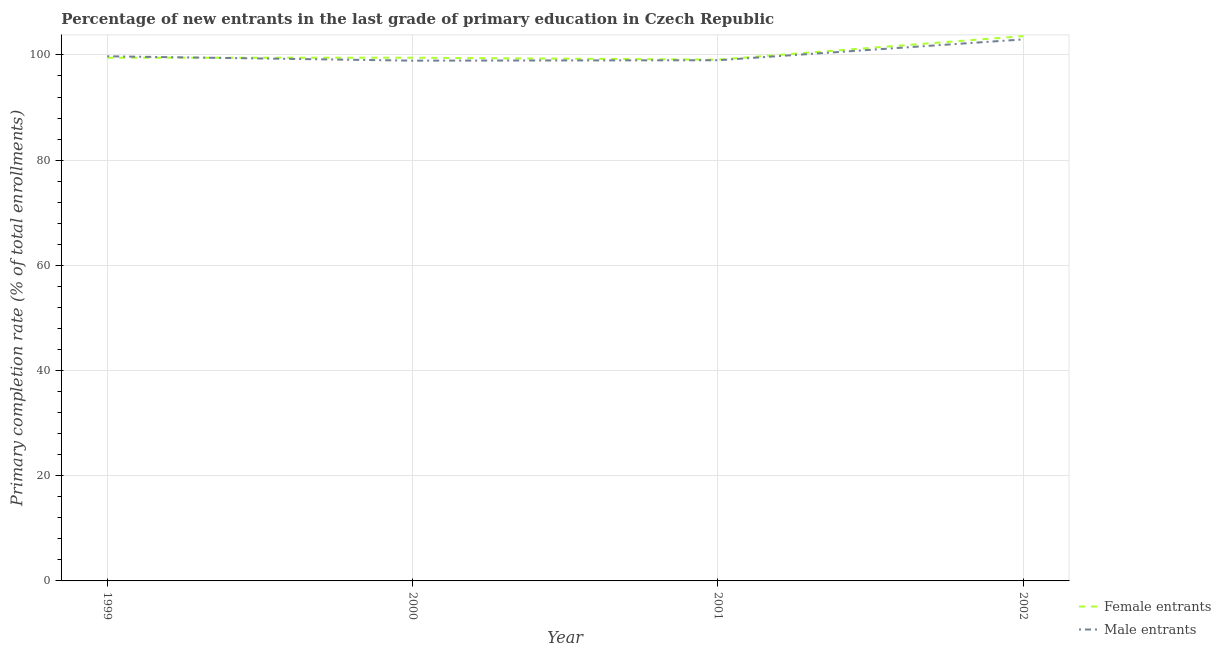Is the number of lines equal to the number of legend labels?
Your answer should be very brief. Yes. What is the primary completion rate of male entrants in 1999?
Offer a terse response. 99.75. Across all years, what is the maximum primary completion rate of female entrants?
Your response must be concise. 103.58. Across all years, what is the minimum primary completion rate of male entrants?
Provide a succinct answer. 98.92. What is the total primary completion rate of female entrants in the graph?
Offer a terse response. 401.64. What is the difference between the primary completion rate of male entrants in 1999 and that in 2001?
Keep it short and to the point. 0.75. What is the difference between the primary completion rate of male entrants in 2000 and the primary completion rate of female entrants in 2001?
Your answer should be compact. -0.19. What is the average primary completion rate of female entrants per year?
Your answer should be very brief. 100.41. In the year 2002, what is the difference between the primary completion rate of female entrants and primary completion rate of male entrants?
Your response must be concise. 0.63. What is the ratio of the primary completion rate of female entrants in 1999 to that in 2002?
Provide a succinct answer. 0.96. What is the difference between the highest and the second highest primary completion rate of female entrants?
Provide a short and direct response. 4.11. What is the difference between the highest and the lowest primary completion rate of male entrants?
Offer a very short reply. 4.04. In how many years, is the primary completion rate of male entrants greater than the average primary completion rate of male entrants taken over all years?
Give a very brief answer. 1. Is the sum of the primary completion rate of male entrants in 2000 and 2002 greater than the maximum primary completion rate of female entrants across all years?
Your answer should be very brief. Yes. Does the primary completion rate of male entrants monotonically increase over the years?
Ensure brevity in your answer.  No. Is the primary completion rate of male entrants strictly greater than the primary completion rate of female entrants over the years?
Give a very brief answer. No. How many lines are there?
Your response must be concise. 2. How many years are there in the graph?
Make the answer very short. 4. Where does the legend appear in the graph?
Your response must be concise. Bottom right. What is the title of the graph?
Give a very brief answer. Percentage of new entrants in the last grade of primary education in Czech Republic. What is the label or title of the Y-axis?
Give a very brief answer. Primary completion rate (% of total enrollments). What is the Primary completion rate (% of total enrollments) in Female entrants in 1999?
Make the answer very short. 99.47. What is the Primary completion rate (% of total enrollments) in Male entrants in 1999?
Make the answer very short. 99.75. What is the Primary completion rate (% of total enrollments) in Female entrants in 2000?
Your response must be concise. 99.47. What is the Primary completion rate (% of total enrollments) of Male entrants in 2000?
Make the answer very short. 98.92. What is the Primary completion rate (% of total enrollments) in Female entrants in 2001?
Make the answer very short. 99.11. What is the Primary completion rate (% of total enrollments) of Male entrants in 2001?
Your answer should be compact. 99. What is the Primary completion rate (% of total enrollments) in Female entrants in 2002?
Give a very brief answer. 103.58. What is the Primary completion rate (% of total enrollments) in Male entrants in 2002?
Give a very brief answer. 102.96. Across all years, what is the maximum Primary completion rate (% of total enrollments) in Female entrants?
Your answer should be very brief. 103.58. Across all years, what is the maximum Primary completion rate (% of total enrollments) in Male entrants?
Provide a succinct answer. 102.96. Across all years, what is the minimum Primary completion rate (% of total enrollments) in Female entrants?
Your response must be concise. 99.11. Across all years, what is the minimum Primary completion rate (% of total enrollments) of Male entrants?
Offer a terse response. 98.92. What is the total Primary completion rate (% of total enrollments) in Female entrants in the graph?
Give a very brief answer. 401.64. What is the total Primary completion rate (% of total enrollments) in Male entrants in the graph?
Offer a terse response. 400.62. What is the difference between the Primary completion rate (% of total enrollments) in Female entrants in 1999 and that in 2000?
Your response must be concise. -0. What is the difference between the Primary completion rate (% of total enrollments) in Male entrants in 1999 and that in 2000?
Provide a short and direct response. 0.83. What is the difference between the Primary completion rate (% of total enrollments) of Female entrants in 1999 and that in 2001?
Your answer should be very brief. 0.36. What is the difference between the Primary completion rate (% of total enrollments) in Male entrants in 1999 and that in 2001?
Your answer should be very brief. 0.75. What is the difference between the Primary completion rate (% of total enrollments) of Female entrants in 1999 and that in 2002?
Ensure brevity in your answer.  -4.11. What is the difference between the Primary completion rate (% of total enrollments) of Male entrants in 1999 and that in 2002?
Make the answer very short. -3.21. What is the difference between the Primary completion rate (% of total enrollments) of Female entrants in 2000 and that in 2001?
Keep it short and to the point. 0.36. What is the difference between the Primary completion rate (% of total enrollments) in Male entrants in 2000 and that in 2001?
Keep it short and to the point. -0.08. What is the difference between the Primary completion rate (% of total enrollments) of Female entrants in 2000 and that in 2002?
Offer a terse response. -4.11. What is the difference between the Primary completion rate (% of total enrollments) of Male entrants in 2000 and that in 2002?
Provide a short and direct response. -4.04. What is the difference between the Primary completion rate (% of total enrollments) of Female entrants in 2001 and that in 2002?
Make the answer very short. -4.47. What is the difference between the Primary completion rate (% of total enrollments) in Male entrants in 2001 and that in 2002?
Provide a succinct answer. -3.96. What is the difference between the Primary completion rate (% of total enrollments) in Female entrants in 1999 and the Primary completion rate (% of total enrollments) in Male entrants in 2000?
Provide a succinct answer. 0.55. What is the difference between the Primary completion rate (% of total enrollments) of Female entrants in 1999 and the Primary completion rate (% of total enrollments) of Male entrants in 2001?
Your answer should be very brief. 0.48. What is the difference between the Primary completion rate (% of total enrollments) in Female entrants in 1999 and the Primary completion rate (% of total enrollments) in Male entrants in 2002?
Offer a terse response. -3.48. What is the difference between the Primary completion rate (% of total enrollments) of Female entrants in 2000 and the Primary completion rate (% of total enrollments) of Male entrants in 2001?
Your response must be concise. 0.48. What is the difference between the Primary completion rate (% of total enrollments) in Female entrants in 2000 and the Primary completion rate (% of total enrollments) in Male entrants in 2002?
Provide a short and direct response. -3.48. What is the difference between the Primary completion rate (% of total enrollments) of Female entrants in 2001 and the Primary completion rate (% of total enrollments) of Male entrants in 2002?
Your answer should be very brief. -3.85. What is the average Primary completion rate (% of total enrollments) of Female entrants per year?
Offer a very short reply. 100.41. What is the average Primary completion rate (% of total enrollments) of Male entrants per year?
Make the answer very short. 100.15. In the year 1999, what is the difference between the Primary completion rate (% of total enrollments) in Female entrants and Primary completion rate (% of total enrollments) in Male entrants?
Provide a short and direct response. -0.28. In the year 2000, what is the difference between the Primary completion rate (% of total enrollments) of Female entrants and Primary completion rate (% of total enrollments) of Male entrants?
Give a very brief answer. 0.56. In the year 2001, what is the difference between the Primary completion rate (% of total enrollments) of Female entrants and Primary completion rate (% of total enrollments) of Male entrants?
Provide a short and direct response. 0.11. In the year 2002, what is the difference between the Primary completion rate (% of total enrollments) in Female entrants and Primary completion rate (% of total enrollments) in Male entrants?
Offer a very short reply. 0.63. What is the ratio of the Primary completion rate (% of total enrollments) in Male entrants in 1999 to that in 2000?
Ensure brevity in your answer.  1.01. What is the ratio of the Primary completion rate (% of total enrollments) in Female entrants in 1999 to that in 2001?
Provide a succinct answer. 1. What is the ratio of the Primary completion rate (% of total enrollments) in Male entrants in 1999 to that in 2001?
Make the answer very short. 1.01. What is the ratio of the Primary completion rate (% of total enrollments) in Female entrants in 1999 to that in 2002?
Provide a succinct answer. 0.96. What is the ratio of the Primary completion rate (% of total enrollments) in Male entrants in 1999 to that in 2002?
Offer a very short reply. 0.97. What is the ratio of the Primary completion rate (% of total enrollments) of Female entrants in 2000 to that in 2001?
Your response must be concise. 1. What is the ratio of the Primary completion rate (% of total enrollments) of Female entrants in 2000 to that in 2002?
Offer a terse response. 0.96. What is the ratio of the Primary completion rate (% of total enrollments) in Male entrants in 2000 to that in 2002?
Your response must be concise. 0.96. What is the ratio of the Primary completion rate (% of total enrollments) of Female entrants in 2001 to that in 2002?
Provide a short and direct response. 0.96. What is the ratio of the Primary completion rate (% of total enrollments) of Male entrants in 2001 to that in 2002?
Offer a terse response. 0.96. What is the difference between the highest and the second highest Primary completion rate (% of total enrollments) of Female entrants?
Give a very brief answer. 4.11. What is the difference between the highest and the second highest Primary completion rate (% of total enrollments) in Male entrants?
Your answer should be compact. 3.21. What is the difference between the highest and the lowest Primary completion rate (% of total enrollments) in Female entrants?
Offer a very short reply. 4.47. What is the difference between the highest and the lowest Primary completion rate (% of total enrollments) in Male entrants?
Provide a short and direct response. 4.04. 